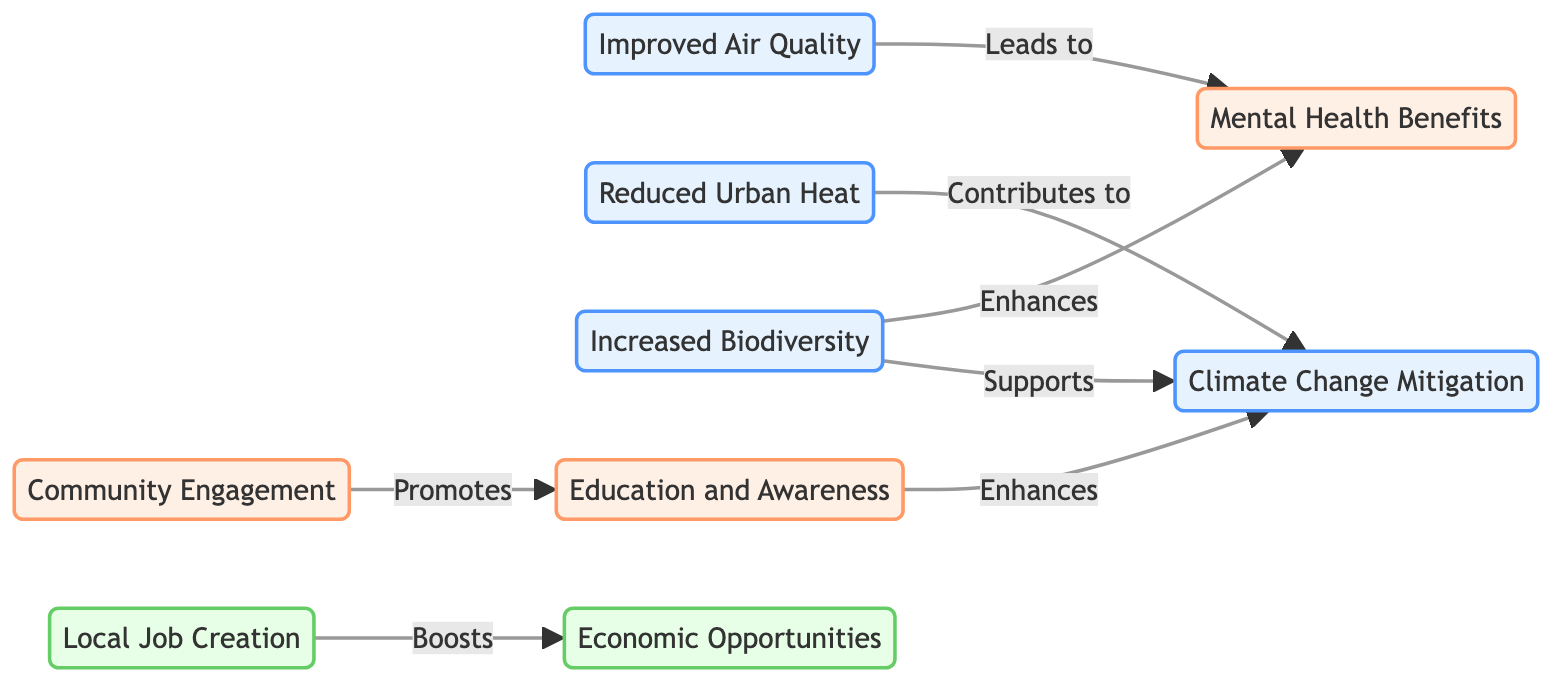What are the environmental benefits listed in the diagram? The diagram shows three environmental benefits: Improved Air Quality, Reduced Urban Heat, and Increased Biodiversity.
Answer: Improved Air Quality, Reduced Urban Heat, Increased Biodiversity How many social benefits are identified in the diagram? The diagram identifies three social benefits: Mental Health Benefits, Community Engagement, and Education and Awareness.
Answer: 3 Which environmental benefit contributes to Climate Change Mitigation? According to the diagram, Reduced Urban Heat contributes to Climate Change Mitigation.
Answer: Reduced Urban Heat What leads to Mental Health Benefits? The diagram indicates that both Improved Air Quality and Increased Biodiversity lead to Mental Health Benefits.
Answer: Improved Air Quality, Increased Biodiversity What does Community Engagement promote? The diagram specifies that Community Engagement promotes Education and Awareness.
Answer: Education and Awareness How many economic benefits are present in the diagram? The diagram presents two economic benefits: Local Job Creation and Economic Opportunities.
Answer: 2 Which two benefits support Climate Change Mitigation according to the diagram? The diagram shows Increased Biodiversity and Education and Awareness as benefits that support Climate Change Mitigation.
Answer: Increased Biodiversity, Education and Awareness What relationship exists between Increased Biodiversity and Mental Health Benefits? The diagram states that Increased Biodiversity enhances Mental Health Benefits.
Answer: Enhances Which benefit boosts Economic Opportunities? The diagram shows that Local Job Creation boosts Economic Opportunities.
Answer: Local Job Creation 